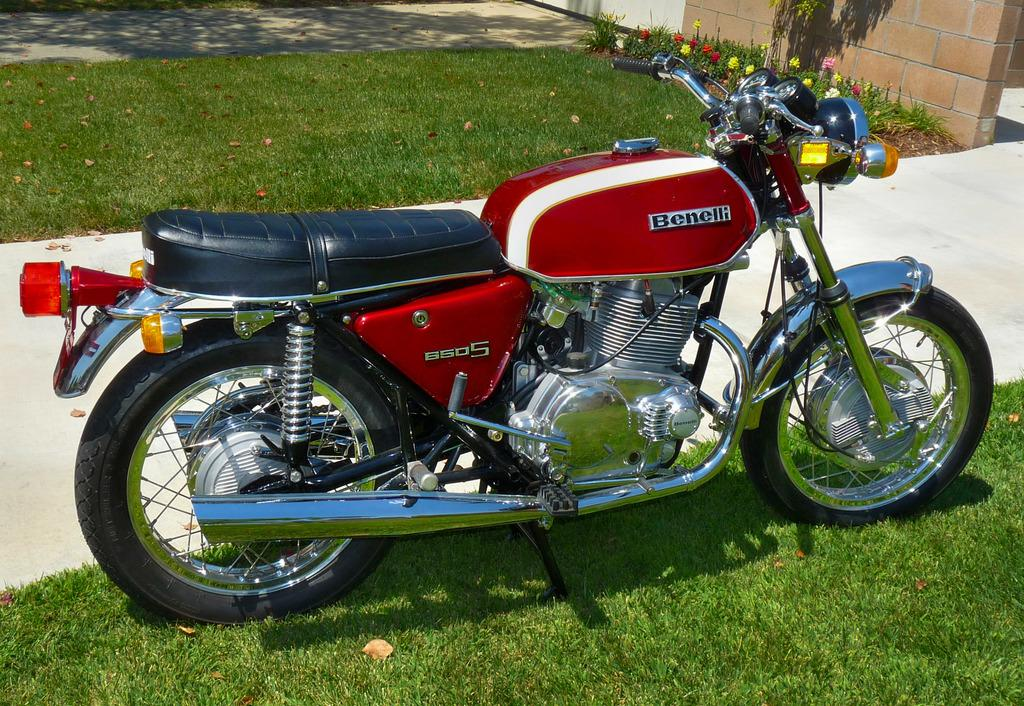What type of vehicle is in the image? There is a motorbike in the image. Where is the motorbike located? The motorbike is parked on the grass. What is behind the motorbike? There is a walkway behind the motorbike. What can be seen in the top part of the image? Flowers, plants, a wall, and grass are visible in the top part of the image. How many legs does the stick have in the image? There is no stick present in the image, so it is not possible to determine how many legs it might have. 